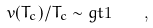Convert formula to latex. <formula><loc_0><loc_0><loc_500><loc_500>v ( T _ { c } ) / T _ { c } \sim g t 1 \quad ,</formula> 